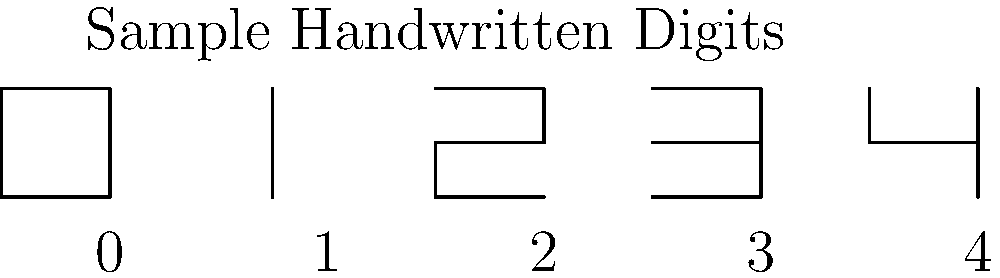As a member of the Lexington school committee evaluating new educational technologies, you're presented with a machine learning model for recognizing handwritten digits. Given the sample images above, which digit would likely be the most challenging for the model to recognize accurately, and why? To answer this question, we need to consider the characteristics of each digit and how they might be interpreted by a machine learning model:

1. The digit 0 is a clear, closed loop, which is distinctive and easily recognizable.
2. The digit 1 is a simple vertical line, also quite distinctive.
3. The digit 2 has a clear curve at the top and a horizontal line at the bottom, making it easily distinguishable.
4. The digit 3 has two clear curves and no straight horizontal lines, giving it a unique shape.
5. The digit 4 in this sample is written in an open style, without the top horizontal line connecting to the vertical line.

Among these, the digit 4 is likely to be the most challenging for the model to recognize accurately for the following reasons:

a) It's written in an unconventional style compared to the typical closed-top 4.
b) The open top could be mistaken for other digits like 7 or 9 if the model hasn't been trained on various writing styles.
c) The lack of a closed shape (unlike 0) and the presence of both vertical and horizontal lines make it more complex than digits like 1 or 7.
d) The intersection of lines in the middle could be confused with similar features in digits like 8 or 9 if the image quality is poor or the writing is unclear.

This potential for misclassification makes the digit 4 the most likely candidate for recognition challenges in this set of samples.
Answer: 4 (due to its unconventional open-top style and potential for misclassification) 